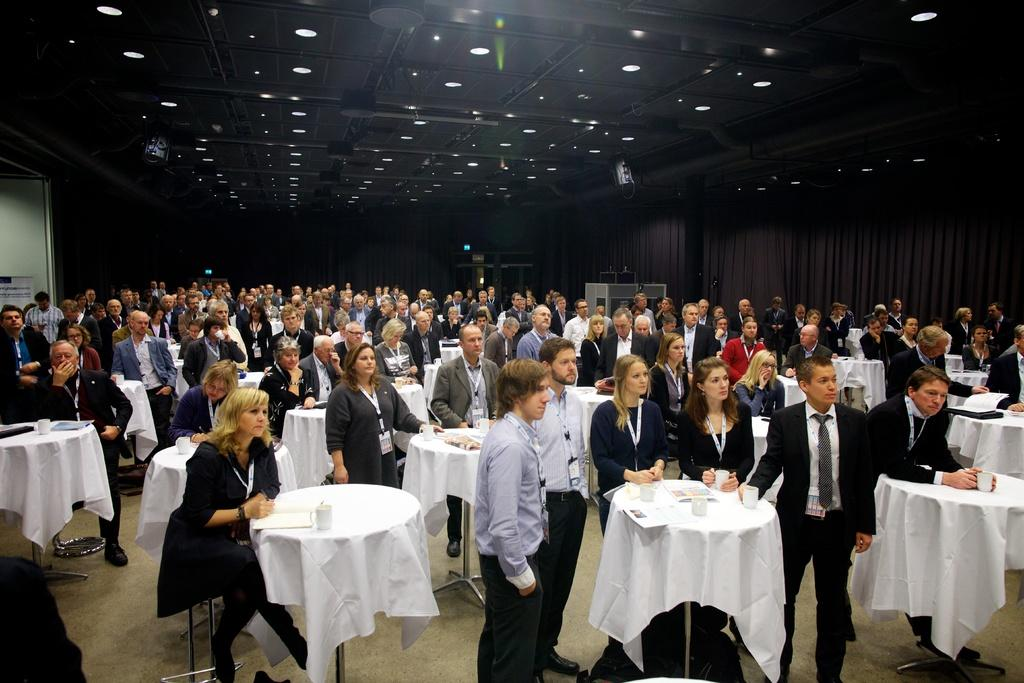How many people are in the group visible in the image? There is a group of people in the image, but the exact number cannot be determined from the provided facts. What objects are on the table in the image? There are cups and papers on the table in the image. What is covering the table in the image? The table is covered with a white cloth. What can be seen on the right side of the image? There are curtains on the right side of the image. What is visible at the top of the image? There are lights visible at the top of the image. Can you tell me how many times the person in the image jumps in the air? There is no person jumping in the air in the image; it features a group of people, cups, papers, a white tablecloth, curtains, and lights. What type of gun is visible in the image? There is no gun present in the image. 